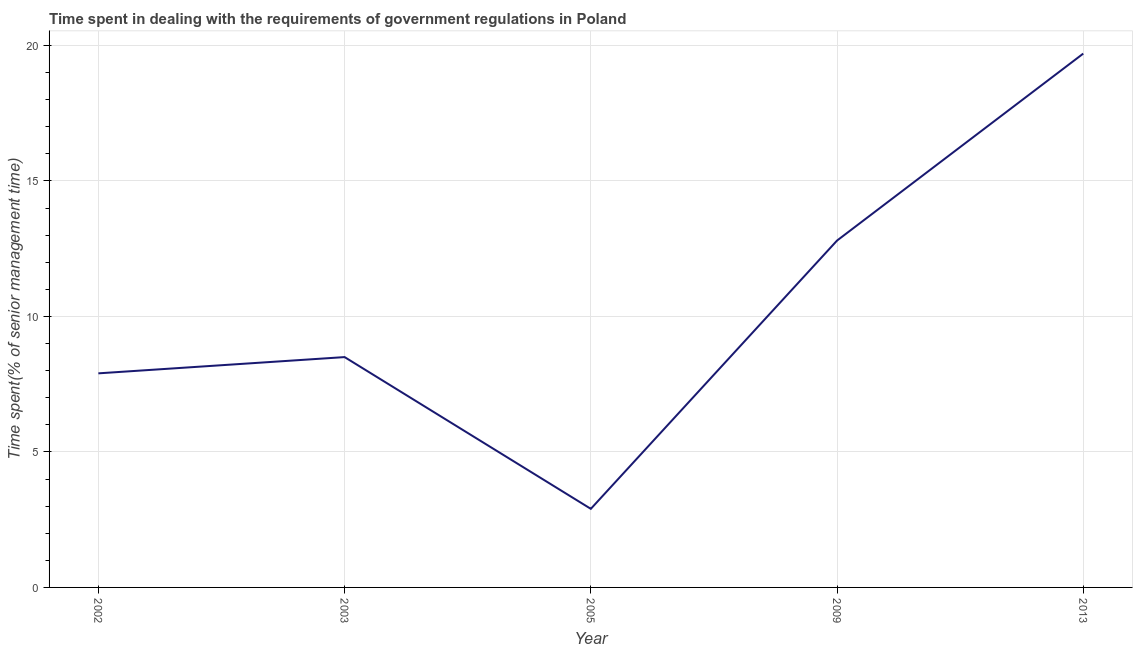Across all years, what is the maximum time spent in dealing with government regulations?
Your answer should be compact. 19.7. In which year was the time spent in dealing with government regulations maximum?
Provide a succinct answer. 2013. What is the sum of the time spent in dealing with government regulations?
Your answer should be compact. 51.8. What is the difference between the time spent in dealing with government regulations in 2003 and 2009?
Make the answer very short. -4.3. What is the average time spent in dealing with government regulations per year?
Offer a terse response. 10.36. Do a majority of the years between 2013 and 2002 (inclusive) have time spent in dealing with government regulations greater than 14 %?
Ensure brevity in your answer.  Yes. What is the ratio of the time spent in dealing with government regulations in 2005 to that in 2009?
Ensure brevity in your answer.  0.23. Is the time spent in dealing with government regulations in 2003 less than that in 2005?
Keep it short and to the point. No. What is the difference between the highest and the second highest time spent in dealing with government regulations?
Ensure brevity in your answer.  6.9. What is the difference between the highest and the lowest time spent in dealing with government regulations?
Offer a very short reply. 16.8. In how many years, is the time spent in dealing with government regulations greater than the average time spent in dealing with government regulations taken over all years?
Your response must be concise. 2. Does the time spent in dealing with government regulations monotonically increase over the years?
Ensure brevity in your answer.  No. How many years are there in the graph?
Offer a terse response. 5. Does the graph contain any zero values?
Offer a terse response. No. What is the title of the graph?
Offer a terse response. Time spent in dealing with the requirements of government regulations in Poland. What is the label or title of the Y-axis?
Your answer should be compact. Time spent(% of senior management time). What is the Time spent(% of senior management time) in 2009?
Your answer should be very brief. 12.8. What is the Time spent(% of senior management time) in 2013?
Make the answer very short. 19.7. What is the difference between the Time spent(% of senior management time) in 2003 and 2013?
Ensure brevity in your answer.  -11.2. What is the difference between the Time spent(% of senior management time) in 2005 and 2009?
Keep it short and to the point. -9.9. What is the difference between the Time spent(% of senior management time) in 2005 and 2013?
Your answer should be compact. -16.8. What is the difference between the Time spent(% of senior management time) in 2009 and 2013?
Ensure brevity in your answer.  -6.9. What is the ratio of the Time spent(% of senior management time) in 2002 to that in 2003?
Provide a short and direct response. 0.93. What is the ratio of the Time spent(% of senior management time) in 2002 to that in 2005?
Give a very brief answer. 2.72. What is the ratio of the Time spent(% of senior management time) in 2002 to that in 2009?
Offer a very short reply. 0.62. What is the ratio of the Time spent(% of senior management time) in 2002 to that in 2013?
Make the answer very short. 0.4. What is the ratio of the Time spent(% of senior management time) in 2003 to that in 2005?
Your answer should be compact. 2.93. What is the ratio of the Time spent(% of senior management time) in 2003 to that in 2009?
Ensure brevity in your answer.  0.66. What is the ratio of the Time spent(% of senior management time) in 2003 to that in 2013?
Offer a terse response. 0.43. What is the ratio of the Time spent(% of senior management time) in 2005 to that in 2009?
Your answer should be compact. 0.23. What is the ratio of the Time spent(% of senior management time) in 2005 to that in 2013?
Offer a very short reply. 0.15. What is the ratio of the Time spent(% of senior management time) in 2009 to that in 2013?
Give a very brief answer. 0.65. 